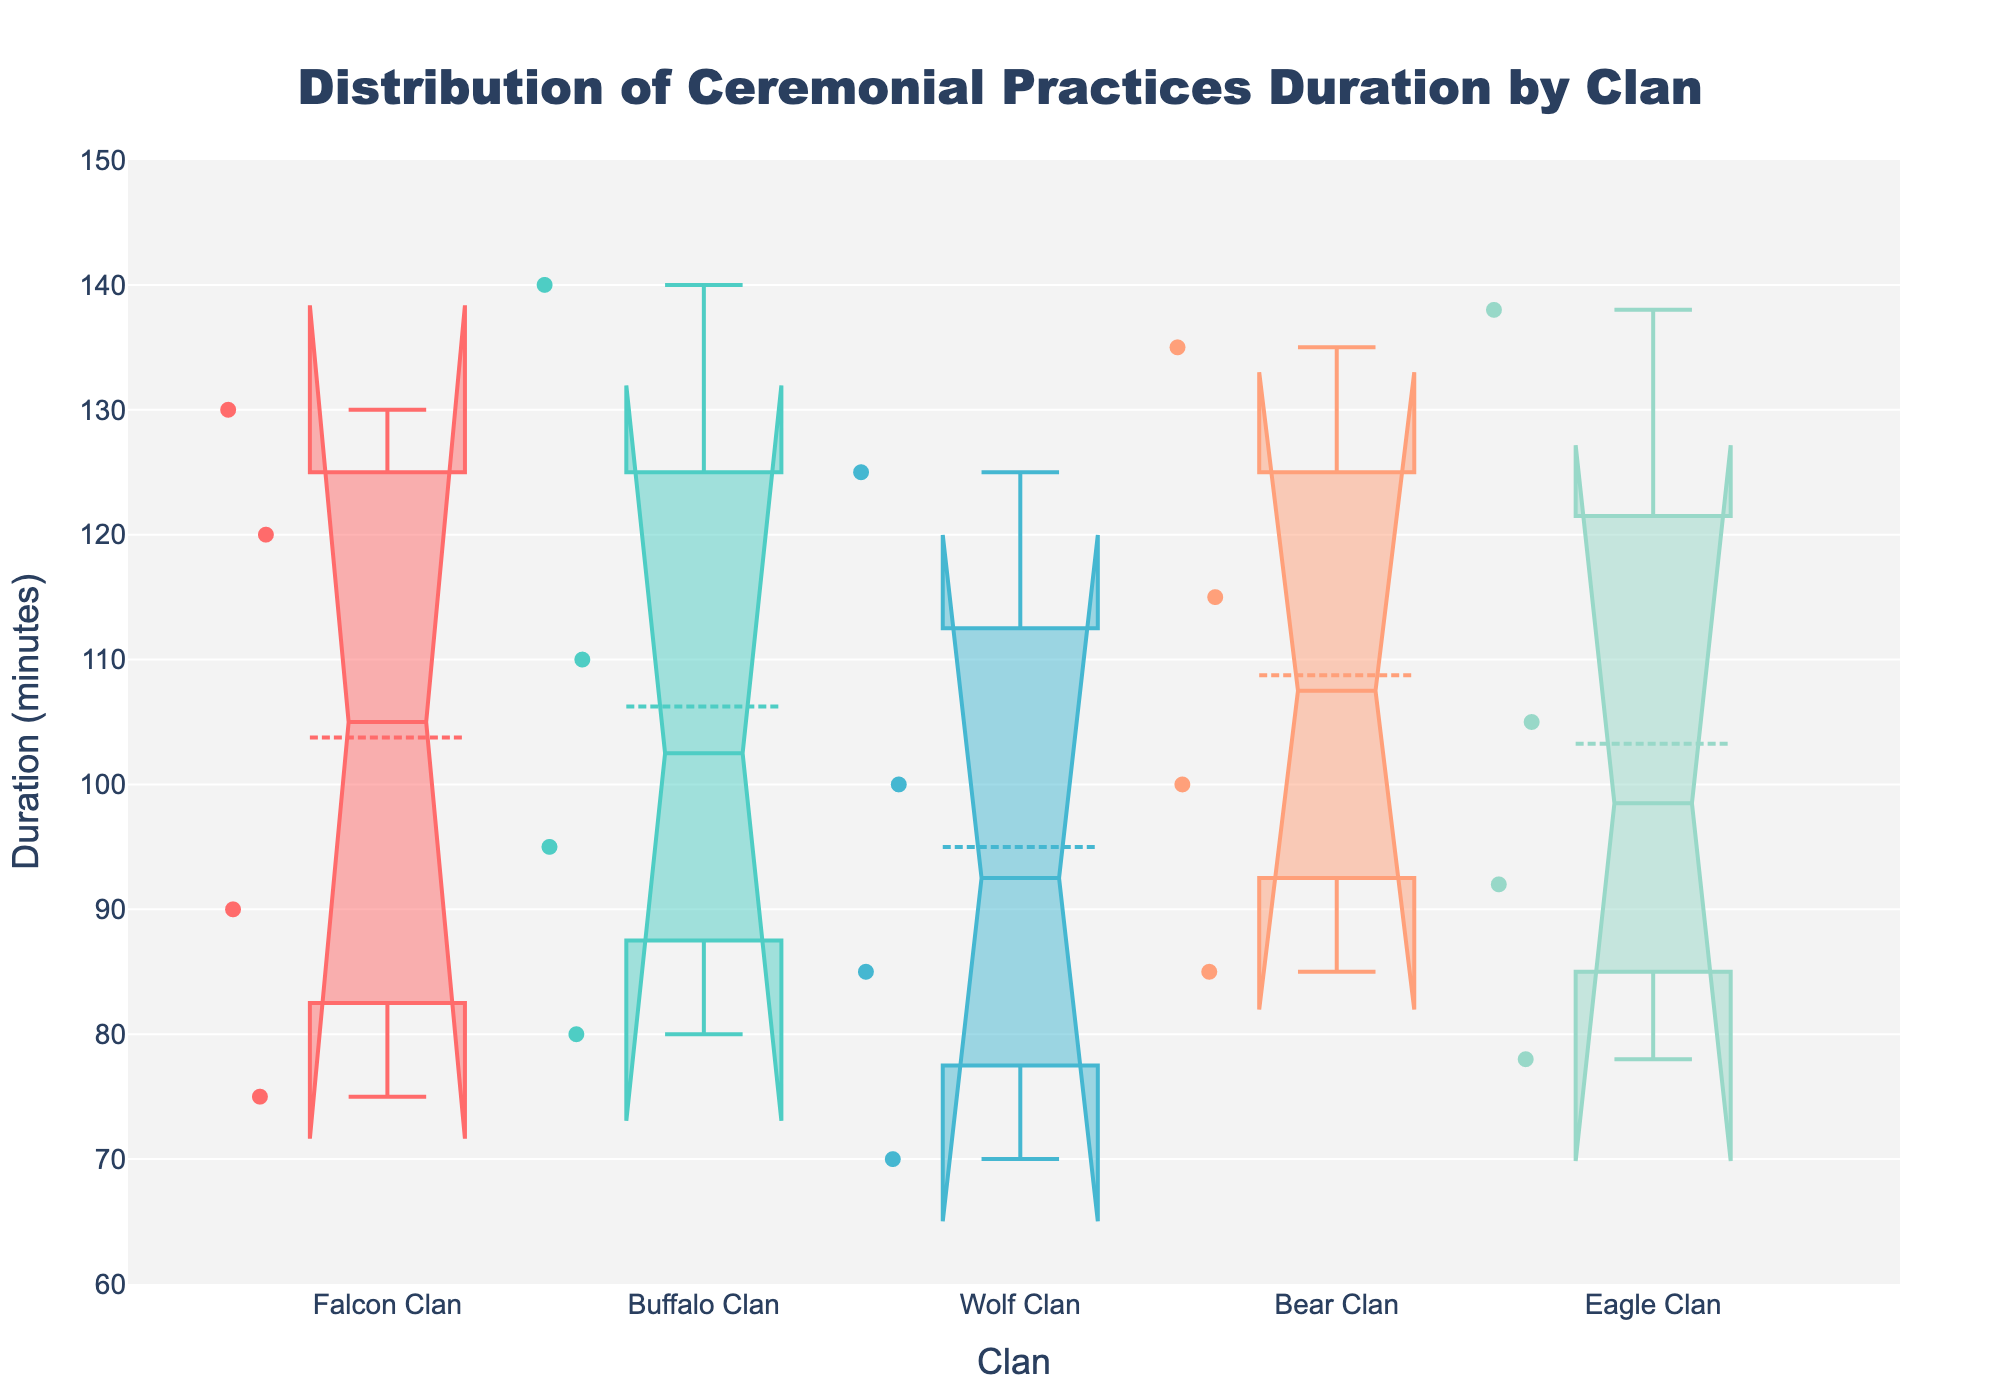What is the title of the figure? The title is located at the top of the figure and typically describes what the figure is about.
Answer: Distribution of Ceremonial Practices Duration by Clan What does the y-axis represent? The y-axis title specifies what is being measured vertically in minutes.
Answer: Duration (minutes) Which clan shows the widest spread in the duration of their ceremonies? The spread (or range) can be determined by the vertical length of the box and whiskers for each clan. The widest spread belongs to the clan with the longest range.
Answer: Buffalo Clan What is the median duration of ceremonies for the Wolf Clan? The median is indicated by the line inside the box of the Wolf Clan's box plot.
Answer: 92.5 minutes Which clan has the shortest median ceremony duration? The shortest median is found by identifying the lowest central line in all the box plots.
Answer: Wolf Clan Compare the range of the Hunting Ritual ceremony durations between the Falcon Clan and the Bear Clan. Which one has a larger range? The range can be calculated by subtracting the lowest value from the highest value for the Hunting Rituals in each clan.
Answer: Bear Clan Which clan's Solar Festival has the highest median duration? The median duration for each clan's Solar Festival can be observed from the middle line within each box plot dedicated to Solar Festivals.
Answer: Buffalo Clan Are there any outliers in the Falcon Clan's ceremony durations? Outliers are shown as individual points outside the whiskers of the box plot. There is one outlier point that is visually identifiable.
Answer: Yes What specific ceremony has the highest duration in the Eagle Clan? By looking at the topmost points or edges for the Eagle Clan, we can find the ceremony with the highest duration.
Answer: Solar Festival Does the notch in the box plot for the Bear Clan's Harvest Festival Dance overlap with the notch for the Buffalo Clan's Harvest Festival Dance? What does this indicate? The notches represent the confidence interval around the median; overlapping notches suggest non-significant differences between medians. Checking the figures visually for overlap.
Answer: Yes, it indicates a non-significant difference in medians 